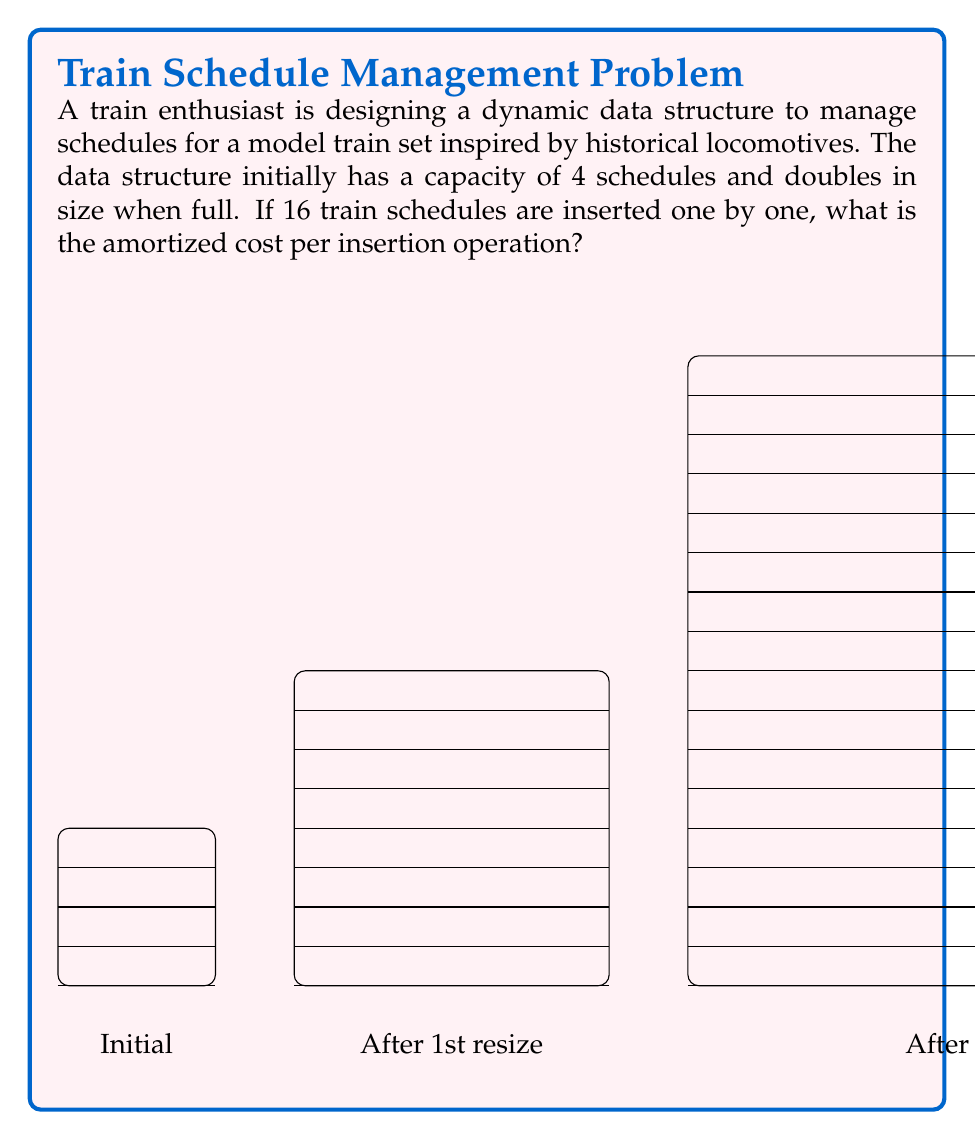Show me your answer to this math problem. Let's approach this step-by-step:

1) We start with a capacity of 4 and double each time we're full. So the sequence of capacities is 4, 8, 16.

2) Let's count the number of element moves:
   - First 4 insertions: no resizing, so 0 moves
   - 5th insertion: resize to 8, copy 4 elements, so 4 moves
   - 6th to 8th insertion: no resizing, so 0 moves
   - 9th insertion: resize to 16, copy 8 elements, so 8 moves
   - 10th to 16th insertion: no resizing, so 0 moves

3) Total number of element moves: 4 + 8 = 12

4) Total number of insertions: 16

5) To calculate the amortized cost, we use the aggregate method:
   Amortized cost = (Total cost) / (Number of operations)
   
   Here, the total cost is the sum of insertion operations and element moves:
   Total cost = 16 (insertions) + 12 (moves) = 28

6) Therefore, the amortized cost per operation is:

   $$\frac{\text{Total cost}}{\text{Number of operations}} = \frac{28}{16} = 1.75$$

This means that on average, each insertion operation costs 1.75 units.
Answer: 1.75 